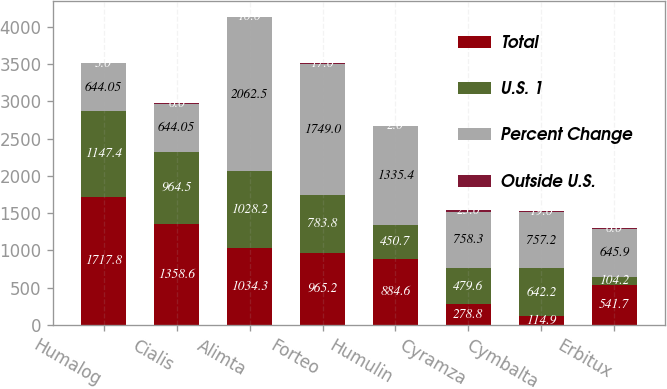<chart> <loc_0><loc_0><loc_500><loc_500><stacked_bar_chart><ecel><fcel>Humalog<fcel>Cialis<fcel>Alimta<fcel>Forteo<fcel>Humulin<fcel>Cyramza<fcel>Cymbalta<fcel>Erbitux<nl><fcel>Total<fcel>1717.8<fcel>1358.6<fcel>1034.3<fcel>965.2<fcel>884.6<fcel>278.8<fcel>114.9<fcel>541.7<nl><fcel>U.S. 1<fcel>1147.4<fcel>964.5<fcel>1028.2<fcel>783.8<fcel>450.7<fcel>479.6<fcel>642.2<fcel>104.2<nl><fcel>Percent Change<fcel>644.05<fcel>644.05<fcel>2062.5<fcel>1749<fcel>1335.4<fcel>758.3<fcel>757.2<fcel>645.9<nl><fcel>Outside U.S.<fcel>3<fcel>6<fcel>10<fcel>17<fcel>2<fcel>23<fcel>19<fcel>6<nl></chart> 